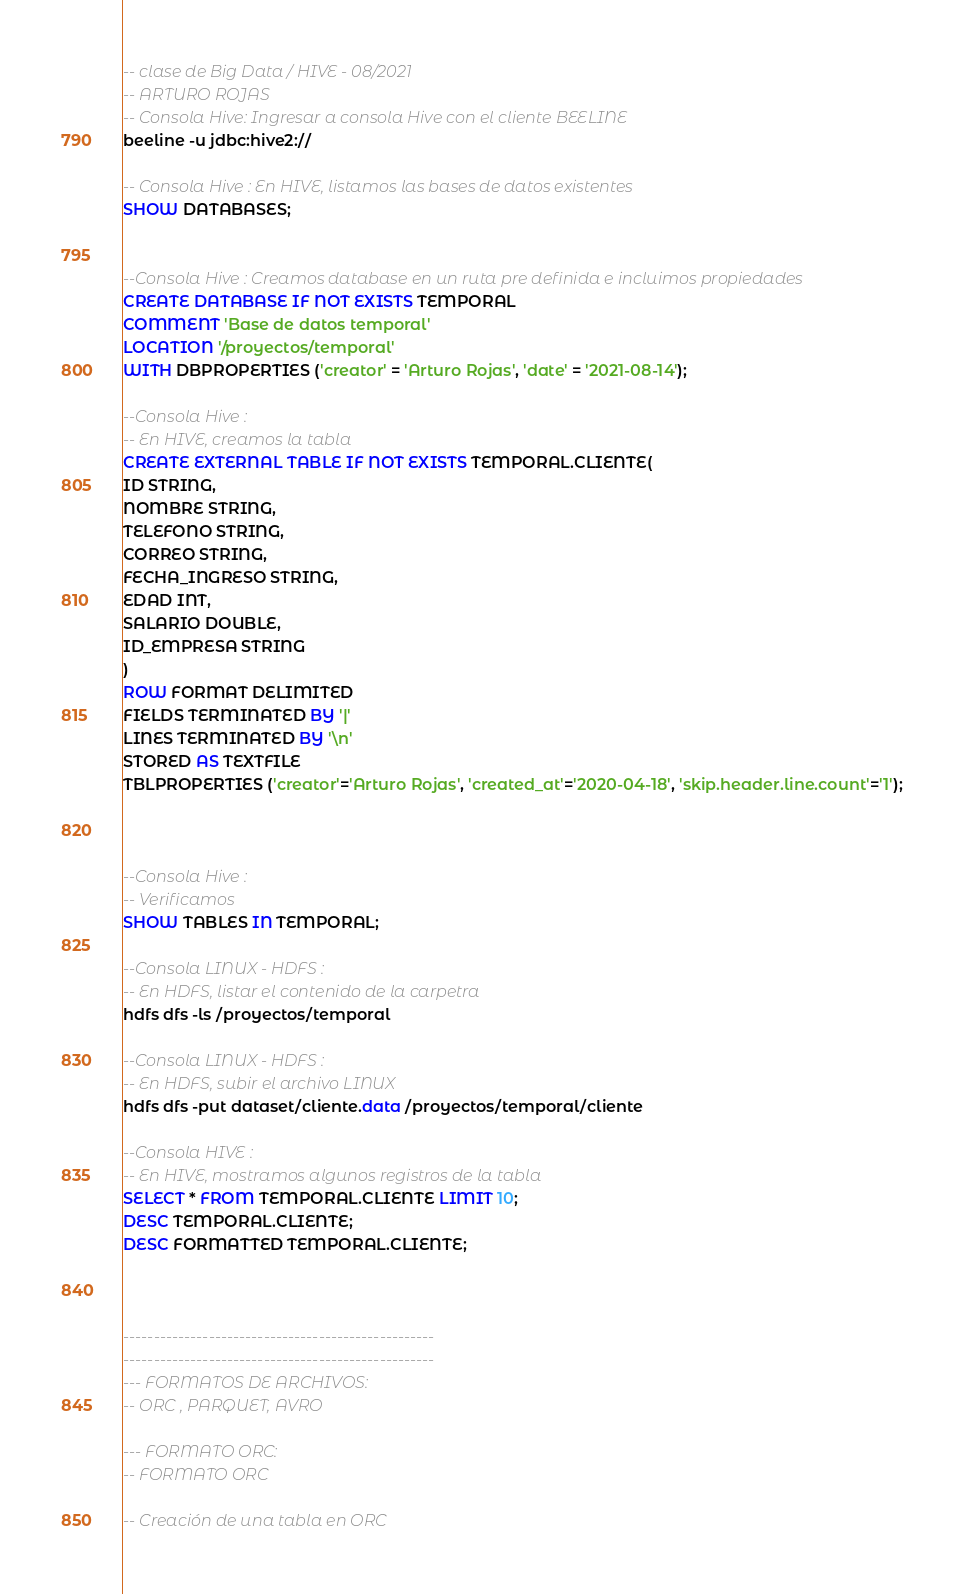<code> <loc_0><loc_0><loc_500><loc_500><_SQL_>-- clase de Big Data / HIVE - 08/2021
-- ARTURO ROJAS
-- Consola Hive: Ingresar a consola Hive con el cliente BEELINE
beeline -u jdbc:hive2://

-- Consola Hive : En HIVE, listamos las bases de datos existentes
SHOW DATABASES;


--Consola Hive : Creamos database en un ruta pre definida e incluimos propiedades
CREATE DATABASE IF NOT EXISTS TEMPORAL 
COMMENT 'Base de datos temporal'
LOCATION '/proyectos/temporal'
WITH DBPROPERTIES ('creator' = 'Arturo Rojas', 'date' = '2021-08-14');

--Consola Hive : 
-- En HIVE, creamos la tabla
CREATE EXTERNAL TABLE IF NOT EXISTS TEMPORAL.CLIENTE(
ID STRING,
NOMBRE STRING,
TELEFONO STRING,
CORREO STRING,
FECHA_INGRESO STRING,
EDAD INT,
SALARIO DOUBLE,
ID_EMPRESA STRING
)
ROW FORMAT DELIMITED
FIELDS TERMINATED BY '|'
LINES TERMINATED BY '\n'
STORED AS TEXTFILE
TBLPROPERTIES ('creator'='Arturo Rojas', 'created_at'='2020-04-18', 'skip.header.line.count'='1');



--Consola Hive : 
-- Verificamos
SHOW TABLES IN TEMPORAL;

--Consola LINUX - HDFS : 
-- En HDFS, listar el contenido de la carpetra 
hdfs dfs -ls /proyectos/temporal

--Consola LINUX - HDFS : 
-- En HDFS, subir el archivo LINUX 
hdfs dfs -put dataset/cliente.data /proyectos/temporal/cliente

--Consola HIVE : 
-- En HIVE, mostramos algunos registros de la tabla
SELECT * FROM TEMPORAL.CLIENTE LIMIT 10;
DESC TEMPORAL.CLIENTE;
DESC FORMATTED TEMPORAL.CLIENTE;



---------------------------------------------------
---------------------------------------------------
--- FORMATOS DE ARCHIVOS:
-- ORC , PARQUET, AVRO

--- FORMATO ORC:
-- FORMATO ORC

-- Creación de una tabla en ORC</code> 